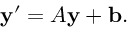<formula> <loc_0><loc_0><loc_500><loc_500>y ^ { \prime } = A y + b .</formula> 